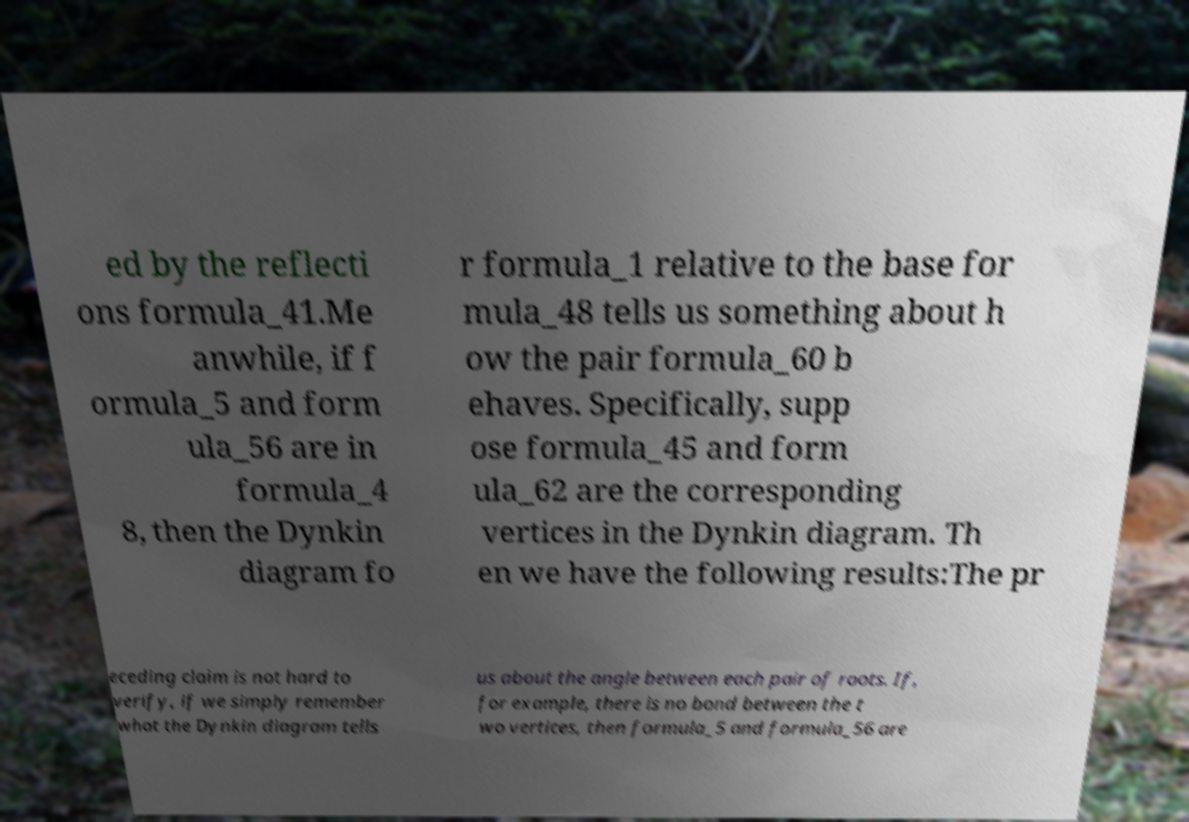Can you accurately transcribe the text from the provided image for me? ed by the reflecti ons formula_41.Me anwhile, if f ormula_5 and form ula_56 are in formula_4 8, then the Dynkin diagram fo r formula_1 relative to the base for mula_48 tells us something about h ow the pair formula_60 b ehaves. Specifically, supp ose formula_45 and form ula_62 are the corresponding vertices in the Dynkin diagram. Th en we have the following results:The pr eceding claim is not hard to verify, if we simply remember what the Dynkin diagram tells us about the angle between each pair of roots. If, for example, there is no bond between the t wo vertices, then formula_5 and formula_56 are 